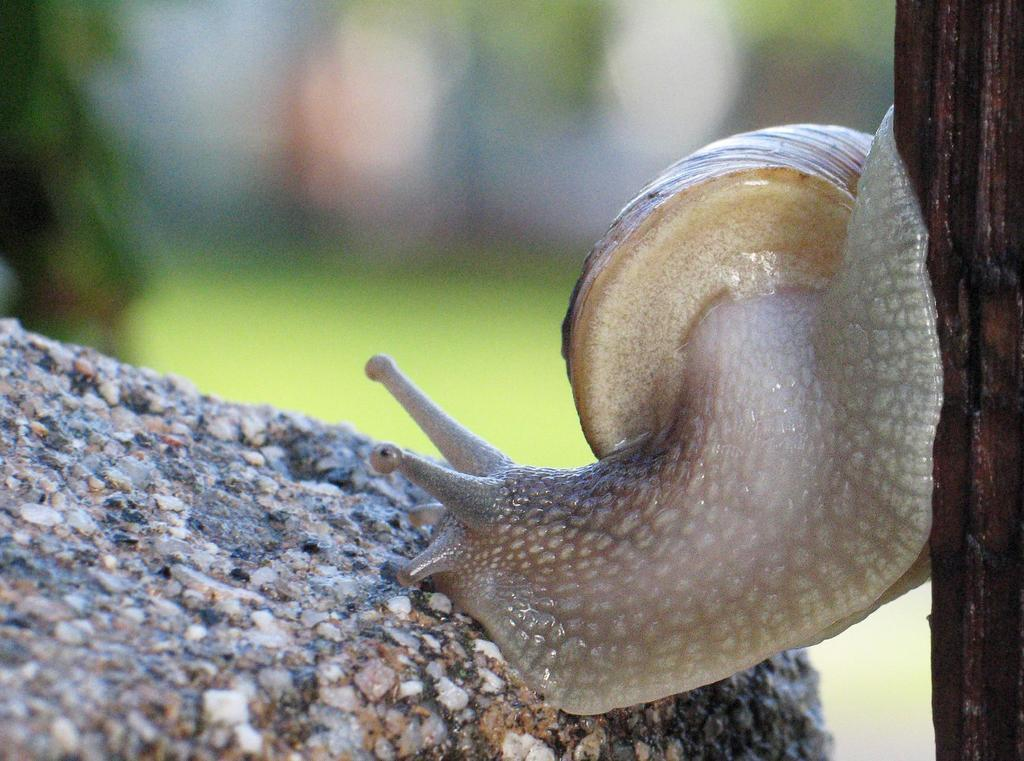What type of ornament is present in the image? There is a snail ornament in the picture. Where is the snail ornament located in the image? The snail ornament is on the right side of the image. What other object can be seen on the opposite side of the image? There is a rock-like object on the left side of the image. What type of treatment is being administered to the snail ornament in the image? There is no treatment being administered to the snail ornament in the image; it is a stationary object. 